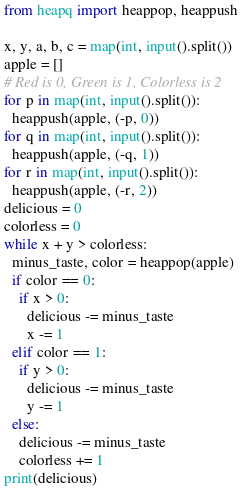Convert code to text. <code><loc_0><loc_0><loc_500><loc_500><_Python_>from heapq import heappop, heappush

x, y, a, b, c = map(int, input().split())
apple = []
# Red is 0, Green is 1, Colorless is 2
for p in map(int, input().split()):
  heappush(apple, (-p, 0))
for q in map(int, input().split()):
  heappush(apple, (-q, 1))
for r in map(int, input().split()):
  heappush(apple, (-r, 2))
delicious = 0
colorless = 0
while x + y > colorless:
  minus_taste, color = heappop(apple)
  if color == 0:
    if x > 0:
      delicious -= minus_taste
      x -= 1
  elif color == 1:
    if y > 0:
      delicious -= minus_taste
      y -= 1
  else:
    delicious -= minus_taste
    colorless += 1
print(delicious)</code> 